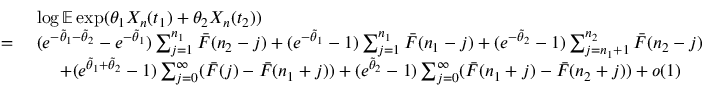<formula> <loc_0><loc_0><loc_500><loc_500>\begin{array} { r l } & { \log \mathbb { E } \exp ( \theta _ { 1 } X _ { n } ( t _ { 1 } ) + \theta _ { 2 } X _ { n } ( t _ { 2 } ) ) } \\ { = } & { ( e ^ { - \tilde { \theta } _ { 1 } - \tilde { \theta } _ { 2 } } - e ^ { - \tilde { \theta } _ { 1 } } ) \sum _ { j = 1 } ^ { n _ { 1 } } \bar { F } ( n _ { 2 } - j ) + ( e ^ { - \tilde { \theta } _ { 1 } } - 1 ) \sum _ { j = 1 } ^ { n _ { 1 } } \bar { F } ( n _ { 1 } - j ) + ( e ^ { - \tilde { \theta } _ { 2 } } - 1 ) \sum _ { j = n _ { 1 } + 1 } ^ { n _ { 2 } } \bar { F } ( n _ { 2 } - j ) } \\ & { + ( e ^ { \tilde { \theta } _ { 1 } + \tilde { \theta } _ { 2 } } - 1 ) \sum _ { j = 0 } ^ { \infty } ( \bar { F } ( j ) - \bar { F } ( n _ { 1 } + j ) ) + ( e ^ { \tilde { \theta } _ { 2 } } - 1 ) \sum _ { j = 0 } ^ { \infty } ( \bar { F } ( n _ { 1 } + j ) - \bar { F } ( n _ { 2 } + j ) ) + o ( 1 ) } \end{array}</formula> 